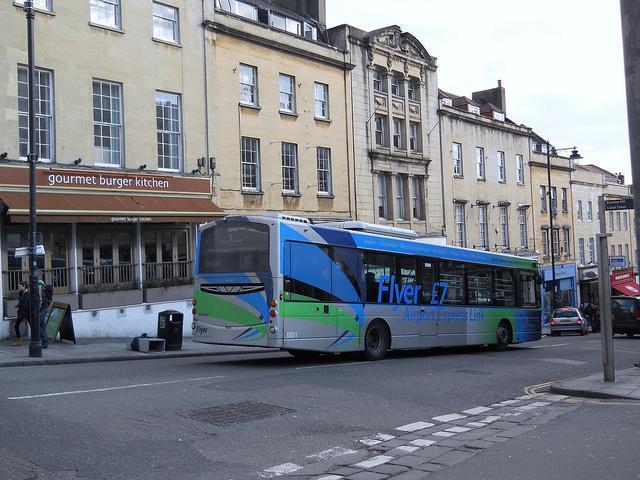What is the bus stopped outside of?
Make your selection from the four choices given to correctly answer the question.
Options: Gas station, restaurant, dentist, library. Restaurant. 